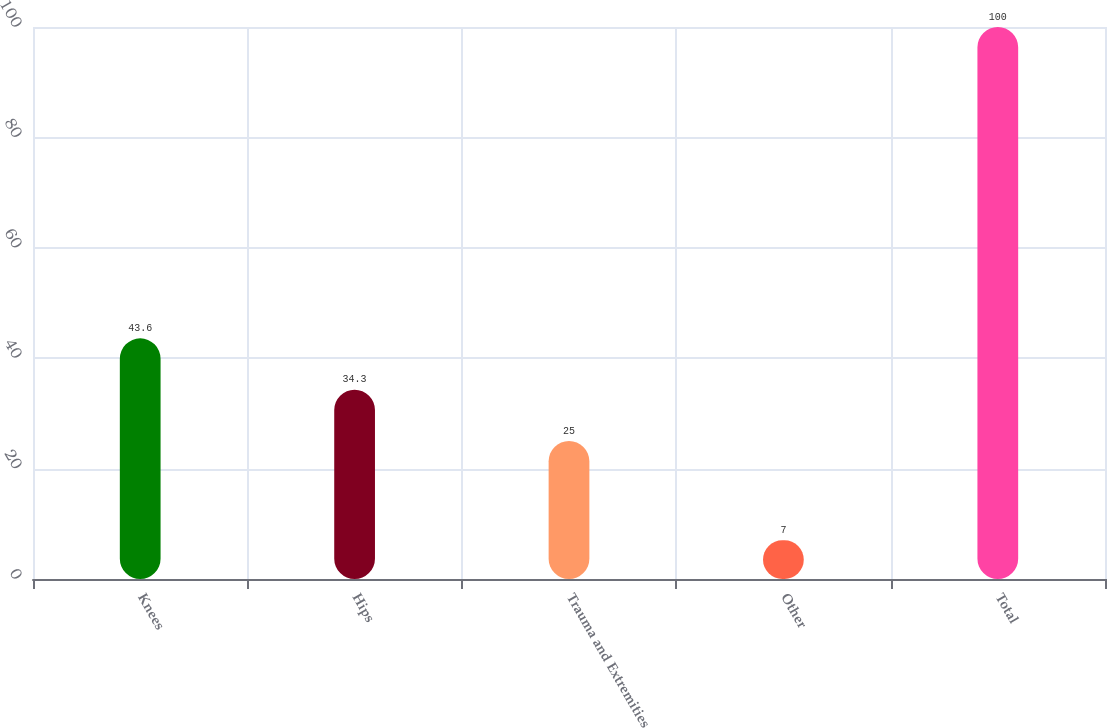Convert chart. <chart><loc_0><loc_0><loc_500><loc_500><bar_chart><fcel>Knees<fcel>Hips<fcel>Trauma and Extremities<fcel>Other<fcel>Total<nl><fcel>43.6<fcel>34.3<fcel>25<fcel>7<fcel>100<nl></chart> 